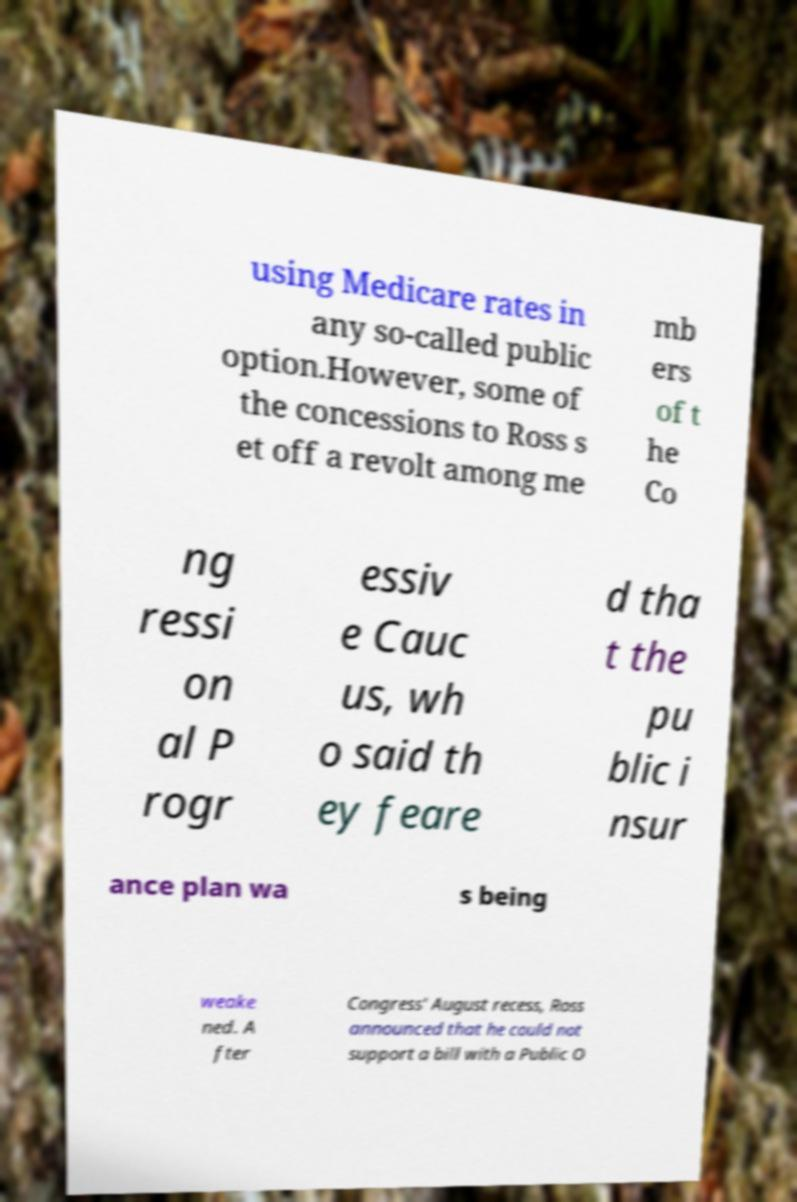Please read and relay the text visible in this image. What does it say? using Medicare rates in any so-called public option.However, some of the concessions to Ross s et off a revolt among me mb ers of t he Co ng ressi on al P rogr essiv e Cauc us, wh o said th ey feare d tha t the pu blic i nsur ance plan wa s being weake ned. A fter Congress' August recess, Ross announced that he could not support a bill with a Public O 